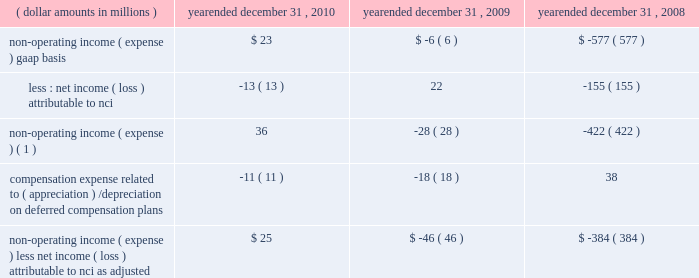4 4 m a n a g e m e n t 2019 s d i s c u s s i o n notes to table ( continued ) ( a ) ( continued ) management believes that operating income , as adjusted , and operating margin , as adjusted , are effective indicators of blackrock 2019s financial performance over time .
As such , management believes that operating income , as adjusted , and operating margin , as adjusted , provide useful disclosure to investors .
Operating income , as adjusted : bgi transaction and integration costs recorded in 2010 and 2009 consist principally of certain advisory payments , compensation expense , legal fees , marketing and promotional , occupancy and consulting expenses incurred in conjunction with the bgi transaction .
Restructuring charges recorded in 2009 and 2008 consist of compensation costs , occupancy costs and professional fees .
The expenses associated with restructuring and bgi transaction and integration costs have been deemed non-recurring by management and have been excluded from operating income , as adjusted , to help enhance the comparability of this information to the current reporting periods .
As such , management believes that operating margins exclusive of these costs are useful measures in evaluating blackrock 2019s operating performance for the respective periods .
The portion of compensation expense associated with certain long-term incentive plans ( 201cltip 201d ) that will be funded through the distribution to participants of shares of blackrock stock held by pnc and a merrill lynch cash compensation contribution , a portion of which has been received , have been excluded because these charges ultimately do not impact blackrock 2019s book value .
Compensation expense associated with appreciation/ ( depreciation ) on investments related to certain blackrock deferred compensation plans has been excluded as returns on investments set aside for these plans , which substantially offset this expense , are reported in non-operating income ( expense ) .
Operating margin , as adjusted : operating income used for measuring operating margin , as adjusted , is equal to operating income , as adjusted , excluding the impact of closed-end fund launch costs and commissions .
Management believes that excluding such costs and commissions is useful because these costs can fluctuate considerably and revenues associated with the expenditure of these costs will not fully impact the company 2019s results until future periods .
Operating margin , as adjusted , allows the company to compare performance from period-to-period by adjusting for items that may not recur , recur infrequently or may fluctuate based on market movements , such as restructuring charges , transaction and integration costs , closed-end fund launch costs , commissions paid to certain employees as compensation and fluctua- tions in compensation expense based on mark-to-market movements in investments held to fund certain compensation plans .
The company also uses operating margin , as adjusted , to monitor corporate performance and efficiency and as a benchmark to compare its performance to other companies .
Management uses both the gaap and non-gaap financial measures in evaluating the financial performance of blackrock .
The non-gaap measure by itself may pose limitations because it does not include all of the company 2019s revenues and expenses .
Revenue used for operating margin , as adjusted , excludes distribution and servicing costs paid to related parties and other third parties .
Management believes that excluding such costs is useful to blackrock because it creates consistency in the treatment for certain contracts for similar services , which due to the terms of the contracts , are accounted for under gaap on a net basis within investment advisory , administration fees and securities lending revenue .
Amortization of deferred sales commissions is excluded from revenue used for operating margin measurement , as adjusted , because such costs , over time , offset distribution fee revenue earned by the company .
Reimbursable property management compensation represented com- pensation and benefits paid to personnel of metric property management , inc .
( 201cmetric 201d ) , a subsidiary of blackrock realty advisors , inc .
( 201crealty 201d ) .
Prior to the transfer in 2008 , these employees were retained on metric 2019s payroll when certain properties were acquired by realty 2019s clients .
The related compensation and benefits were fully reimbursed by realty 2019s clients and have been excluded from revenue used for operating margin , as adjusted , because they did not bear an economic cost to blackrock .
For each of these items , blackrock excludes from revenue used for operating margin , as adjusted , the costs related to each of these items as a proxy for such offsetting revenues .
( b ) non-operating income ( expense ) , less net income ( loss ) attributable to non-controlling interests , as adjusted : non-operating income ( expense ) , less net income ( loss ) attributable to non-controlling interests ( 201cnci 201d ) , as adjusted , equals non-operating income ( expense ) , gaap basis , less net income ( loss ) attributable to nci , gaap basis , adjusted for compensation expense associated with depreciation/ ( appreciation ) on investments related to certain blackrock deferred compensation plans .
The compensation expense offset is recorded in operating income .
This compensation expense has been included in non-operating income ( expense ) , less net income ( loss ) attributable to nci , as adjusted , to offset returns on investments set aside for these plans , which are reported in non-operating income ( expense ) , gaap basis. .
Non-operating income ( expense ) ( 1 ) 36 ( 28 ) ( 422 ) compensation expense related to ( appreciation ) / depreciation on deferred compensation plans ( 11 ) ( 18 ) 38 non-operating income ( expense ) , less net income ( loss ) attributable to nci , as adjusted $ 25 ( $ 46 ) ( $ 384 ) ( 1 ) net of net income ( loss ) attributable to non-controlling interests .
Management believes that non-operating income ( expense ) , less net income ( loss ) attributable to nci , as adjusted , provides for comparability of this information to prior periods and is an effective measure for reviewing blackrock 2019s non-operating contribution to its results .
As compensation expense associated with ( appreciation ) /depreciation on investments related to certain deferred compensation plans , which is included in operating income , offsets the gain/ ( loss ) on the investments set aside for these plans , management believes that non-operating income ( expense ) , less net income ( loss ) attributable to nci , as adjusted , provides a useful measure , for both management and investors , of blackrock 2019s non-operating results that impact book value. .
What is the percent change in non-operating income ( expense ) less net income ( loss ) attributable to nci as adjusted from 2009 to 2010? 
Computations: ((25 + 46) / 46)
Answer: 1.54348. 